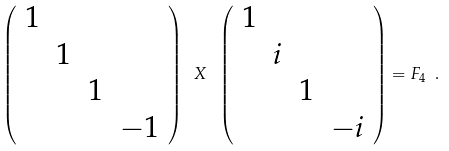<formula> <loc_0><loc_0><loc_500><loc_500>\left ( \begin{array} { r r r r } 1 & & & \\ & 1 & & \\ & & 1 & \\ & & & - 1 \end{array} \right ) \ X \ \left ( \begin{array} { r r r r } 1 & & & \\ & i & & \\ & & 1 & \\ & & & - i \end{array} \right ) = F _ { 4 } \ .</formula> 